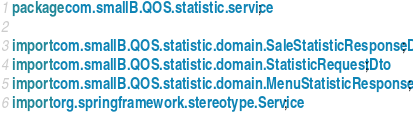Convert code to text. <code><loc_0><loc_0><loc_500><loc_500><_Java_>package com.smallB.QOS.statistic.service;

import com.smallB.QOS.statistic.domain.SaleStatisticResponseDto;
import com.smallB.QOS.statistic.domain.StatisticRequestDto;
import com.smallB.QOS.statistic.domain.MenuStatisticResponseDto;
import org.springframework.stereotype.Service;
</code> 